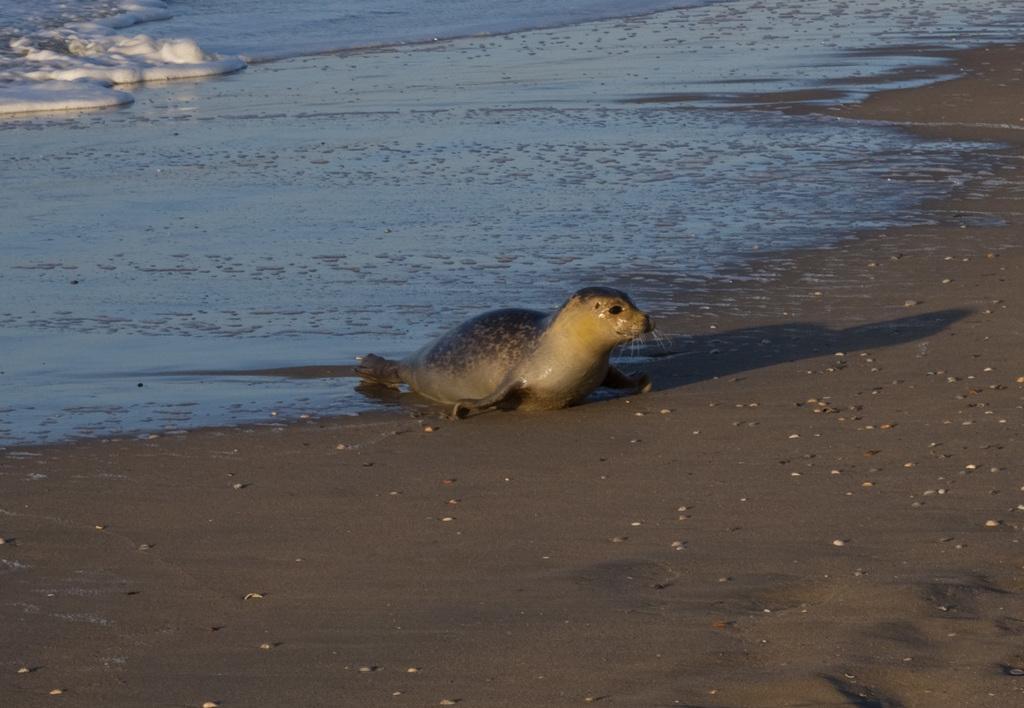Describe this image in one or two sentences. Here in this picture we can see a seal present on the ground over there and behind it we can see water and snow present over there. 